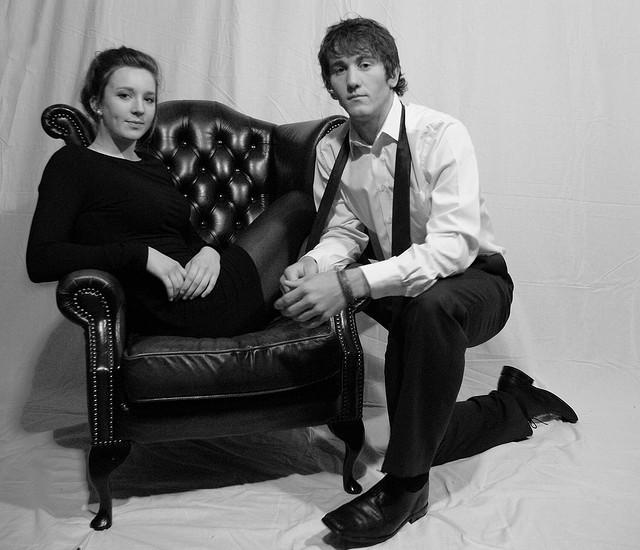Is this man wearing jeans?
Concise answer only. No. Is she going to tie his tie?
Short answer required. No. How many shoes are in the picture?
Keep it brief. 2. 